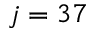<formula> <loc_0><loc_0><loc_500><loc_500>j = 3 7</formula> 